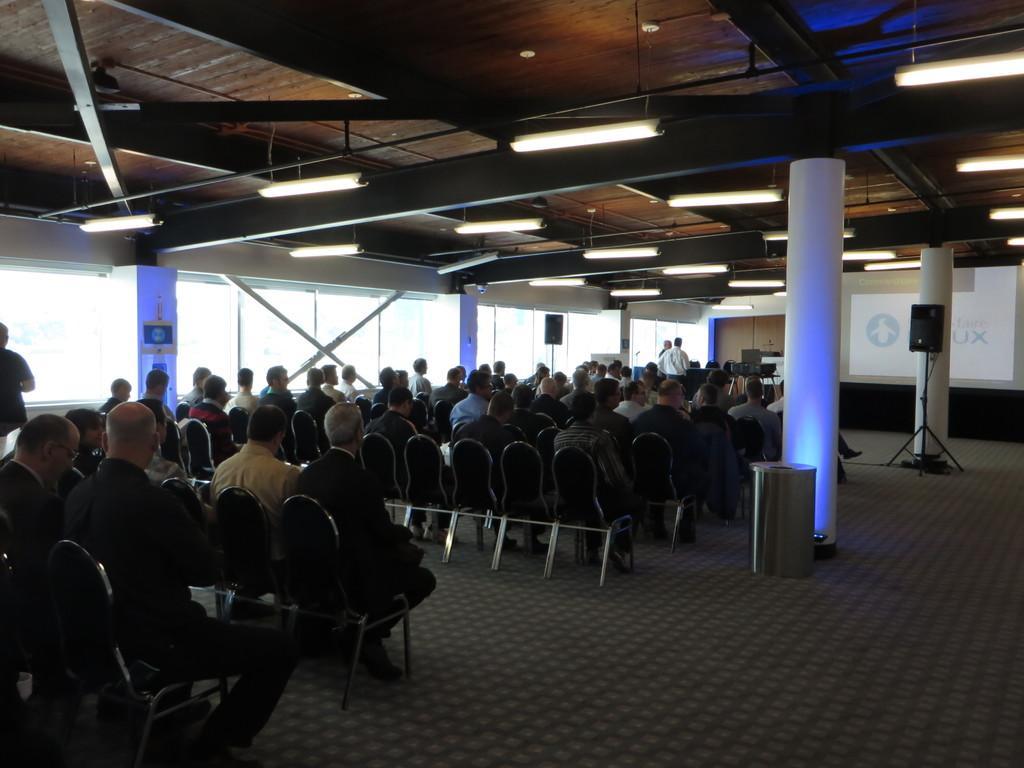Could you give a brief overview of what you see in this image? In this picture I can see there are a few people sitting in the chairs and there are few pillars and there is a screen at right side, there is a glass window at left side. 